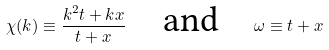Convert formula to latex. <formula><loc_0><loc_0><loc_500><loc_500>\chi ( k ) \equiv \frac { k ^ { 2 } t + k x } { t + x } \quad \text {and\quad } \omega \equiv t + x</formula> 